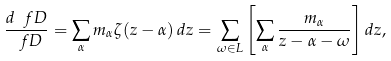<formula> <loc_0><loc_0><loc_500><loc_500>\frac { d \ f D } { \ f D } = \sum _ { \alpha } m _ { \alpha } \zeta ( z - \alpha ) \, d z = \sum _ { \omega \in L } \left [ \sum _ { \alpha } \frac { m _ { \alpha } } { z - \alpha - \omega } \right ] d z ,</formula> 